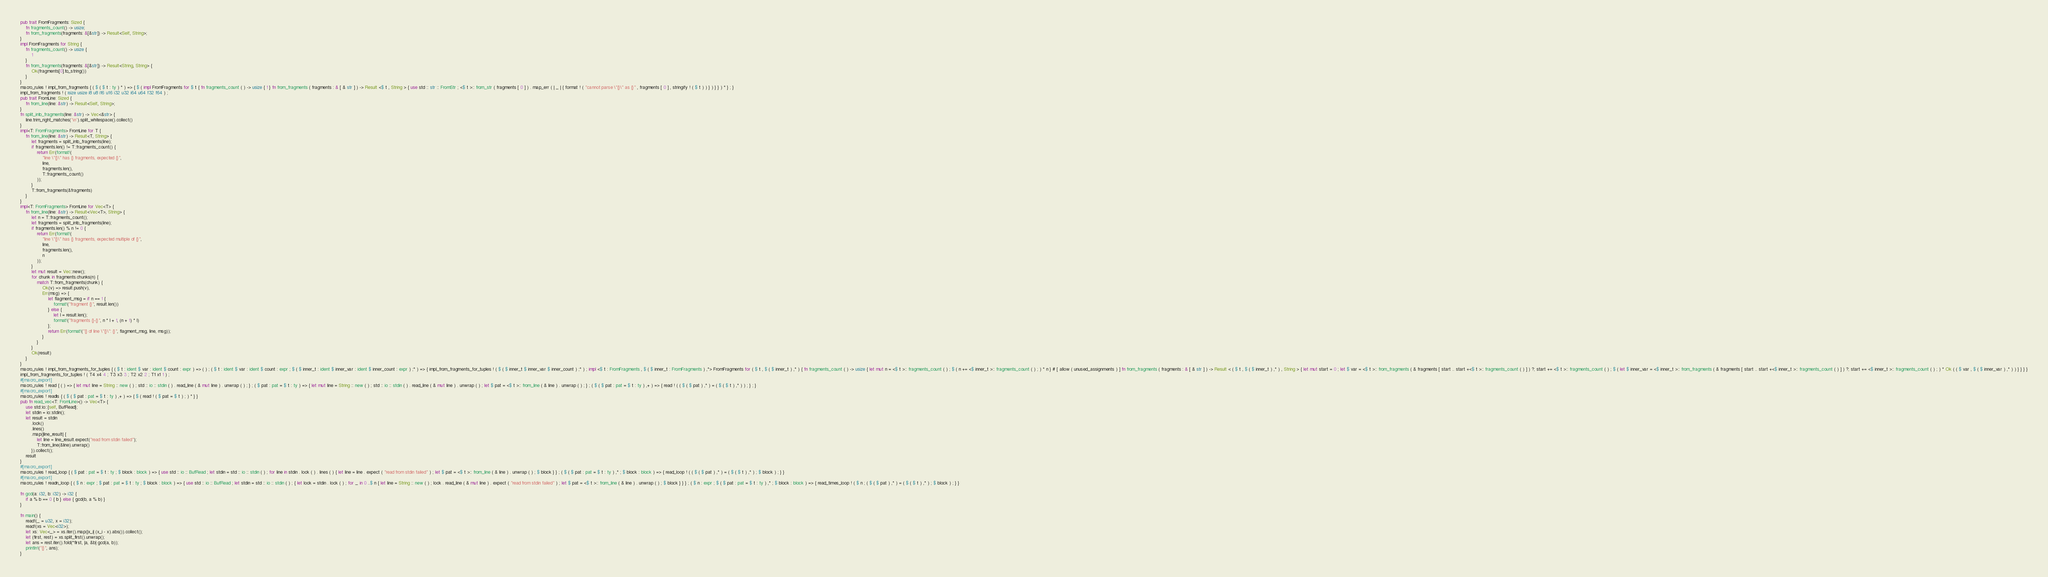<code> <loc_0><loc_0><loc_500><loc_500><_Rust_>pub trait FromFragments: Sized {
    fn fragments_count() -> usize;
    fn from_fragments(fragments: &[&str]) -> Result<Self, String>;
}
impl FromFragments for String {
    fn fragments_count() -> usize {
        1
    }
    fn from_fragments(fragments: &[&str]) -> Result<String, String> {
        Ok(fragments[0].to_string())
    }
}
macro_rules ! impl_from_fragments { ( $ ( $ t : ty ) * ) => { $ ( impl FromFragments for $ t { fn fragments_count ( ) -> usize { 1 } fn from_fragments ( fragments : & [ & str ] ) -> Result <$ t , String > { use std :: str :: FromStr ; <$ t >:: from_str ( fragments [ 0 ] ) . map_err ( | _ | { format ! ( "cannot parse \"{}\" as {}" , fragments [ 0 ] , stringify ! ( $ t ) ) } ) } } ) * } ; }
impl_from_fragments ! ( isize usize i8 u8 i16 u16 i32 u32 i64 u64 f32 f64 ) ;
pub trait FromLine: Sized {
    fn from_line(line: &str) -> Result<Self, String>;
}
fn split_into_fragments(line: &str) -> Vec<&str> {
    line.trim_right_matches('\n').split_whitespace().collect()
}
impl<T: FromFragments> FromLine for T {
    fn from_line(line: &str) -> Result<T, String> {
        let fragments = split_into_fragments(line);
        if fragments.len() != T::fragments_count() {
            return Err(format!(
                "line \"{}\" has {} fragments, expected {}",
                line,
                fragments.len(),
                T::fragments_count()
            ));
        }
        T::from_fragments(&fragments)
    }
}
impl<T: FromFragments> FromLine for Vec<T> {
    fn from_line(line: &str) -> Result<Vec<T>, String> {
        let n = T::fragments_count();
        let fragments = split_into_fragments(line);
        if fragments.len() % n != 0 {
            return Err(format!(
                "line \"{}\" has {} fragments, expected multiple of {}",
                line,
                fragments.len(),
                n
            ));
        }
        let mut result = Vec::new();
        for chunk in fragments.chunks(n) {
            match T::from_fragments(chunk) {
                Ok(v) => result.push(v),
                Err(msg) => {
                    let flagment_msg = if n == 1 {
                        format!("fragment {}", result.len())
                    } else {
                        let l = result.len();
                        format!("fragments {}-{}", n * l + 1, (n + 1) * l)
                    };
                    return Err(format!("{} of line \"{}\": {}", flagment_msg, line, msg));
                }
            }
        }
        Ok(result)
    }
}
macro_rules ! impl_from_fragments_for_tuples { ( $ t : ident $ var : ident $ count : expr ) => ( ) ; ( $ t : ident $ var : ident $ count : expr ; $ ( $ inner_t : ident $ inner_var : ident $ inner_count : expr ) ;* ) => { impl_from_fragments_for_tuples ! ( $ ( $ inner_t $ inner_var $ inner_count ) ;* ) ; impl <$ t : FromFragments , $ ( $ inner_t : FromFragments ) ,*> FromFragments for ( $ t , $ ( $ inner_t ) ,* ) { fn fragments_count ( ) -> usize { let mut n = <$ t >:: fragments_count ( ) ; $ ( n += <$ inner_t >:: fragments_count ( ) ; ) * n } # [ allow ( unused_assignments ) ] fn from_fragments ( fragments : & [ & str ] ) -> Result < ( $ t , $ ( $ inner_t ) ,* ) , String > { let mut start = 0 ; let $ var = <$ t >:: from_fragments ( & fragments [ start .. start +<$ t >:: fragments_count ( ) ] ) ?; start += <$ t >:: fragments_count ( ) ; $ ( let $ inner_var = <$ inner_t >:: from_fragments ( & fragments [ start .. start +<$ inner_t >:: fragments_count ( ) ] ) ?; start += <$ inner_t >:: fragments_count ( ) ; ) * Ok ( ( $ var , $ ( $ inner_var ) ,* ) ) } } } }
impl_from_fragments_for_tuples ! ( T4 x4 4 ; T3 x3 3 ; T2 x2 2 ; T1 x1 1 ) ;
#[macro_export]
macro_rules ! read { ( ) => { let mut line = String :: new ( ) ; std :: io :: stdin ( ) . read_line ( & mut line ) . unwrap ( ) ; } ; ( $ pat : pat = $ t : ty ) => { let mut line = String :: new ( ) ; std :: io :: stdin ( ) . read_line ( & mut line ) . unwrap ( ) ; let $ pat = <$ t >:: from_line ( & line ) . unwrap ( ) ; } ; ( $ ( $ pat : pat = $ t : ty ) ,+ ) => { read ! ( ( $ ( $ pat ) ,* ) = ( $ ( $ t ) ,* ) ) ; } ; }
#[macro_export]
macro_rules ! readls { ( $ ( $ pat : pat = $ t : ty ) ,+ ) => { $ ( read ! ( $ pat = $ t ) ; ) * } }
pub fn read_vec<T: FromLine>() -> Vec<T> {
    use std::io::{self, BufRead};
    let stdin = io::stdin();
    let result = stdin
        .lock()
        .lines()
        .map(|line_result| {
            let line = line_result.expect("read from stdin failed");
            T::from_line(&line).unwrap()
        }).collect();
    result
}
#[macro_export]
macro_rules ! read_loop { ( $ pat : pat = $ t : ty ; $ block : block ) => { use std :: io :: BufRead ; let stdin = std :: io :: stdin ( ) ; for line in stdin . lock ( ) . lines ( ) { let line = line . expect ( "read from stdin failed" ) ; let $ pat = <$ t >:: from_line ( & line ) . unwrap ( ) ; $ block } } ; ( $ ( $ pat : pat = $ t : ty ) ,* ; $ block : block ) => { read_loop ! ( ( $ ( $ pat ) ,* ) = ( $ ( $ t ) ,* ) ; $ block ) ; } }
#[macro_export]
macro_rules ! readn_loop { ( $ n : expr ; $ pat : pat = $ t : ty ; $ block : block ) => { use std :: io :: BufRead ; let stdin = std :: io :: stdin ( ) ; { let lock = stdin . lock ( ) ; for _ in 0 ..$ n { let line = String :: new ( ) ; lock . read_line ( & mut line ) . expect ( "read from stdin failed" ) ; let $ pat = <$ t >:: from_line ( & line ) . unwrap ( ) ; $ block } } } ; ( $ n : expr ; $ ( $ pat : pat = $ t : ty ) ,* ; $ block : block ) => { read_times_loop ! ( $ n ; ( $ ( $ pat ) ,* ) = ( $ ( $ t ) ,* ) ; $ block ) ; } }

fn gcd(a: i32, b: i32) -> i32 {
    if a % b == 0 { b } else { gcd(b, a % b) }
}

fn main() {
    read!(_ = u32, x = i32);
    read!(xs = Vec<i32>);
    let xs: Vec<_> = xs.iter().map(|x_i| (x_i - x).abs()).collect();
    let (first, rest) = xs.split_first().unwrap();
    let ans = rest.iter().fold(*first, |a, &b| gcd(a, b));
    println!("{}", ans);
}
</code> 